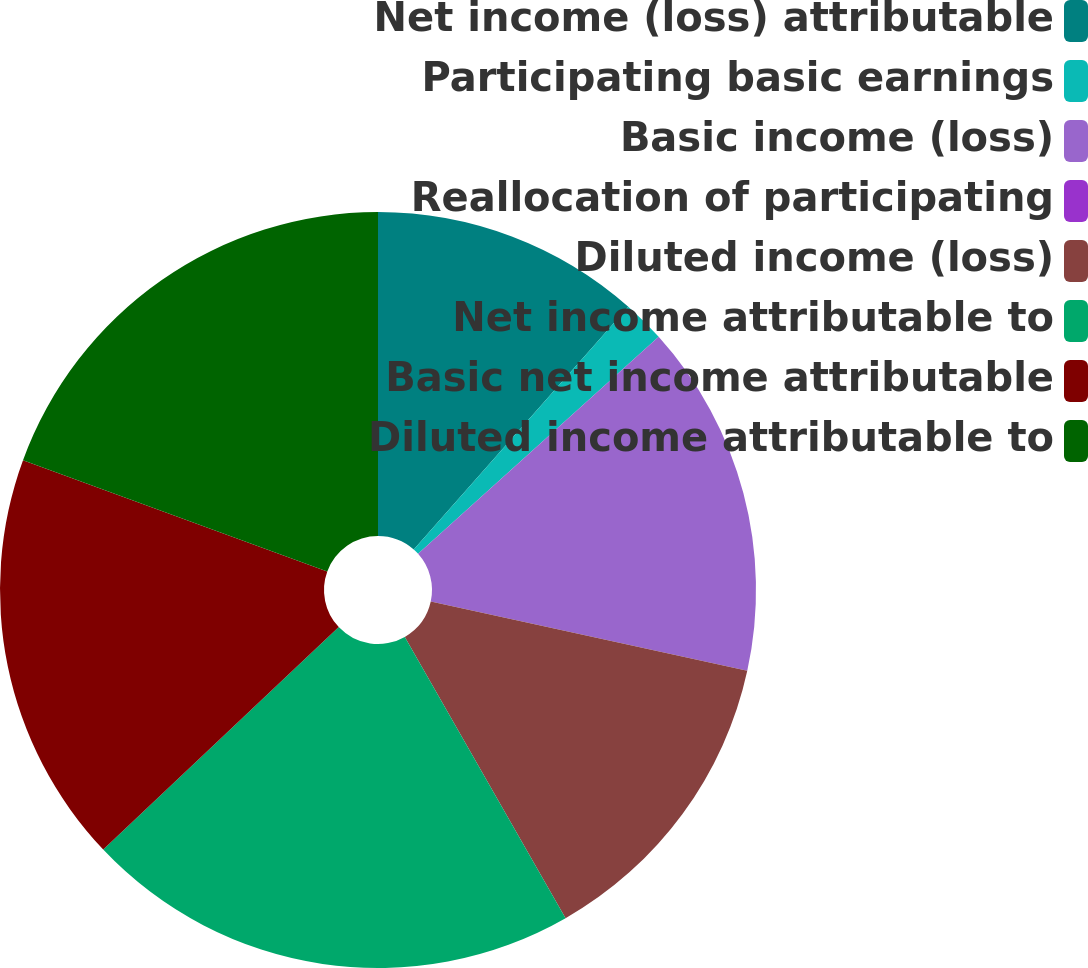Convert chart. <chart><loc_0><loc_0><loc_500><loc_500><pie_chart><fcel>Net income (loss) attributable<fcel>Participating basic earnings<fcel>Basic income (loss)<fcel>Reallocation of participating<fcel>Diluted income (loss)<fcel>Net income attributable to<fcel>Basic net income attributable<fcel>Diluted income attributable to<nl><fcel>11.52%<fcel>1.8%<fcel>15.11%<fcel>0.0%<fcel>13.31%<fcel>21.22%<fcel>17.63%<fcel>19.42%<nl></chart> 